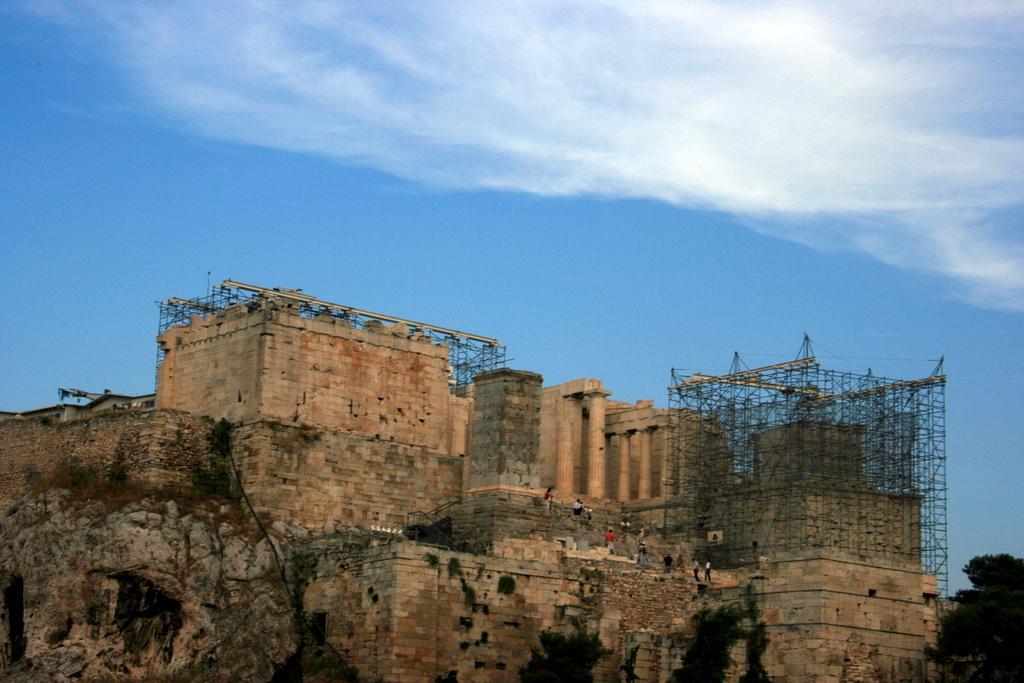Please provide a concise description of this image. In this image, this looks like a building, which is under construction. There are few people standing. On the right corner of the image, It looks like a tree. These are the clouds in the sky. 